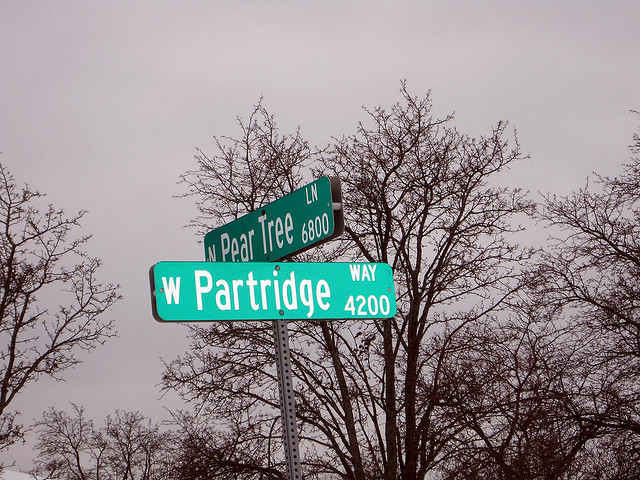<image>What is the name of the Avenue? The name of the avenue is not clearly seen. It could be 'w partridge', 'broad', 'partridge' or 'w partridge way'. What is the name of the Avenue? I don't know the name of the Avenue. It can be 'w partridge', 'broad', 'partridge' or 'w partridge way'. 